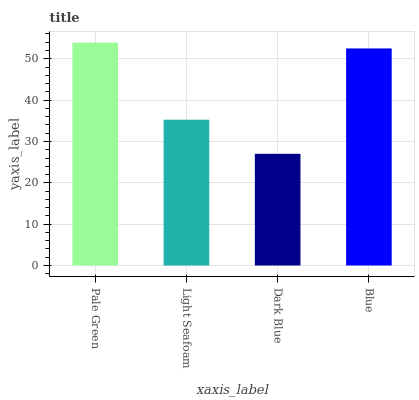Is Dark Blue the minimum?
Answer yes or no. Yes. Is Pale Green the maximum?
Answer yes or no. Yes. Is Light Seafoam the minimum?
Answer yes or no. No. Is Light Seafoam the maximum?
Answer yes or no. No. Is Pale Green greater than Light Seafoam?
Answer yes or no. Yes. Is Light Seafoam less than Pale Green?
Answer yes or no. Yes. Is Light Seafoam greater than Pale Green?
Answer yes or no. No. Is Pale Green less than Light Seafoam?
Answer yes or no. No. Is Blue the high median?
Answer yes or no. Yes. Is Light Seafoam the low median?
Answer yes or no. Yes. Is Pale Green the high median?
Answer yes or no. No. Is Pale Green the low median?
Answer yes or no. No. 